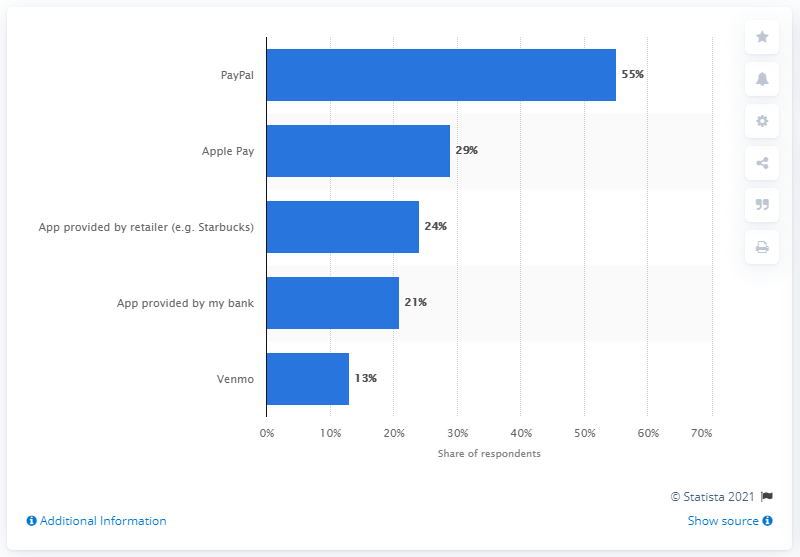Outline some significant characteristics in this image. According to a survey of affluent mobile payment app users, 55% of them reported using PayPal as their preferred payment method. 